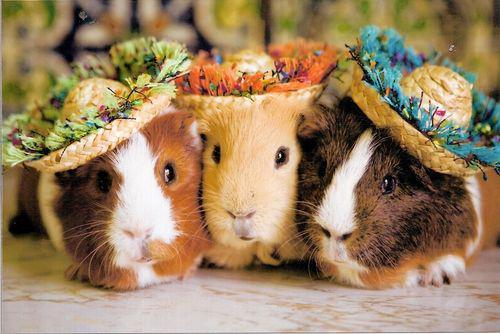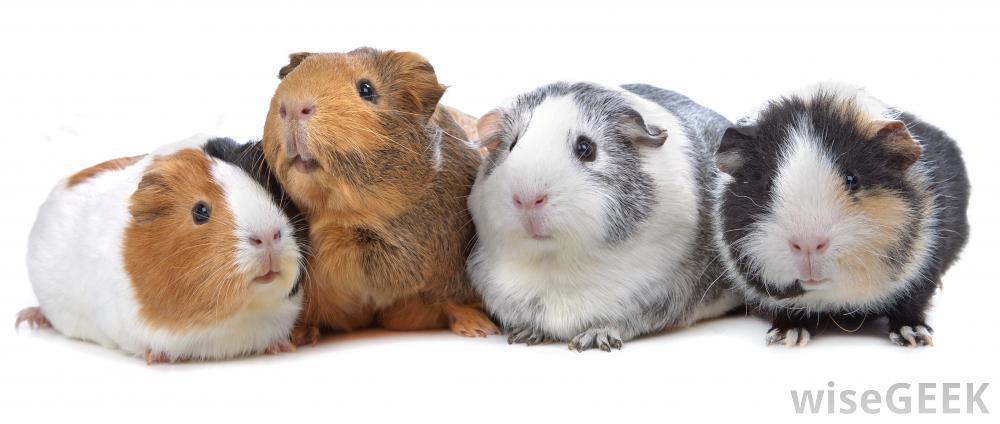The first image is the image on the left, the second image is the image on the right. Considering the images on both sides, is "An image shows exactly four guinea pigs in a horizontal row." valid? Answer yes or no. Yes. The first image is the image on the left, the second image is the image on the right. For the images shown, is this caption "Four rodents sit in a row in one of the images." true? Answer yes or no. Yes. 